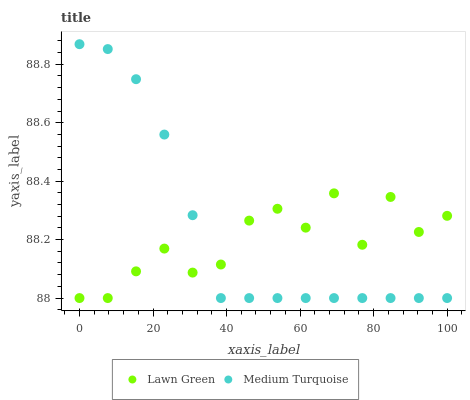Does Lawn Green have the minimum area under the curve?
Answer yes or no. Yes. Does Medium Turquoise have the maximum area under the curve?
Answer yes or no. Yes. Does Medium Turquoise have the minimum area under the curve?
Answer yes or no. No. Is Medium Turquoise the smoothest?
Answer yes or no. Yes. Is Lawn Green the roughest?
Answer yes or no. Yes. Is Medium Turquoise the roughest?
Answer yes or no. No. Does Lawn Green have the lowest value?
Answer yes or no. Yes. Does Medium Turquoise have the highest value?
Answer yes or no. Yes. Does Lawn Green intersect Medium Turquoise?
Answer yes or no. Yes. Is Lawn Green less than Medium Turquoise?
Answer yes or no. No. Is Lawn Green greater than Medium Turquoise?
Answer yes or no. No. 